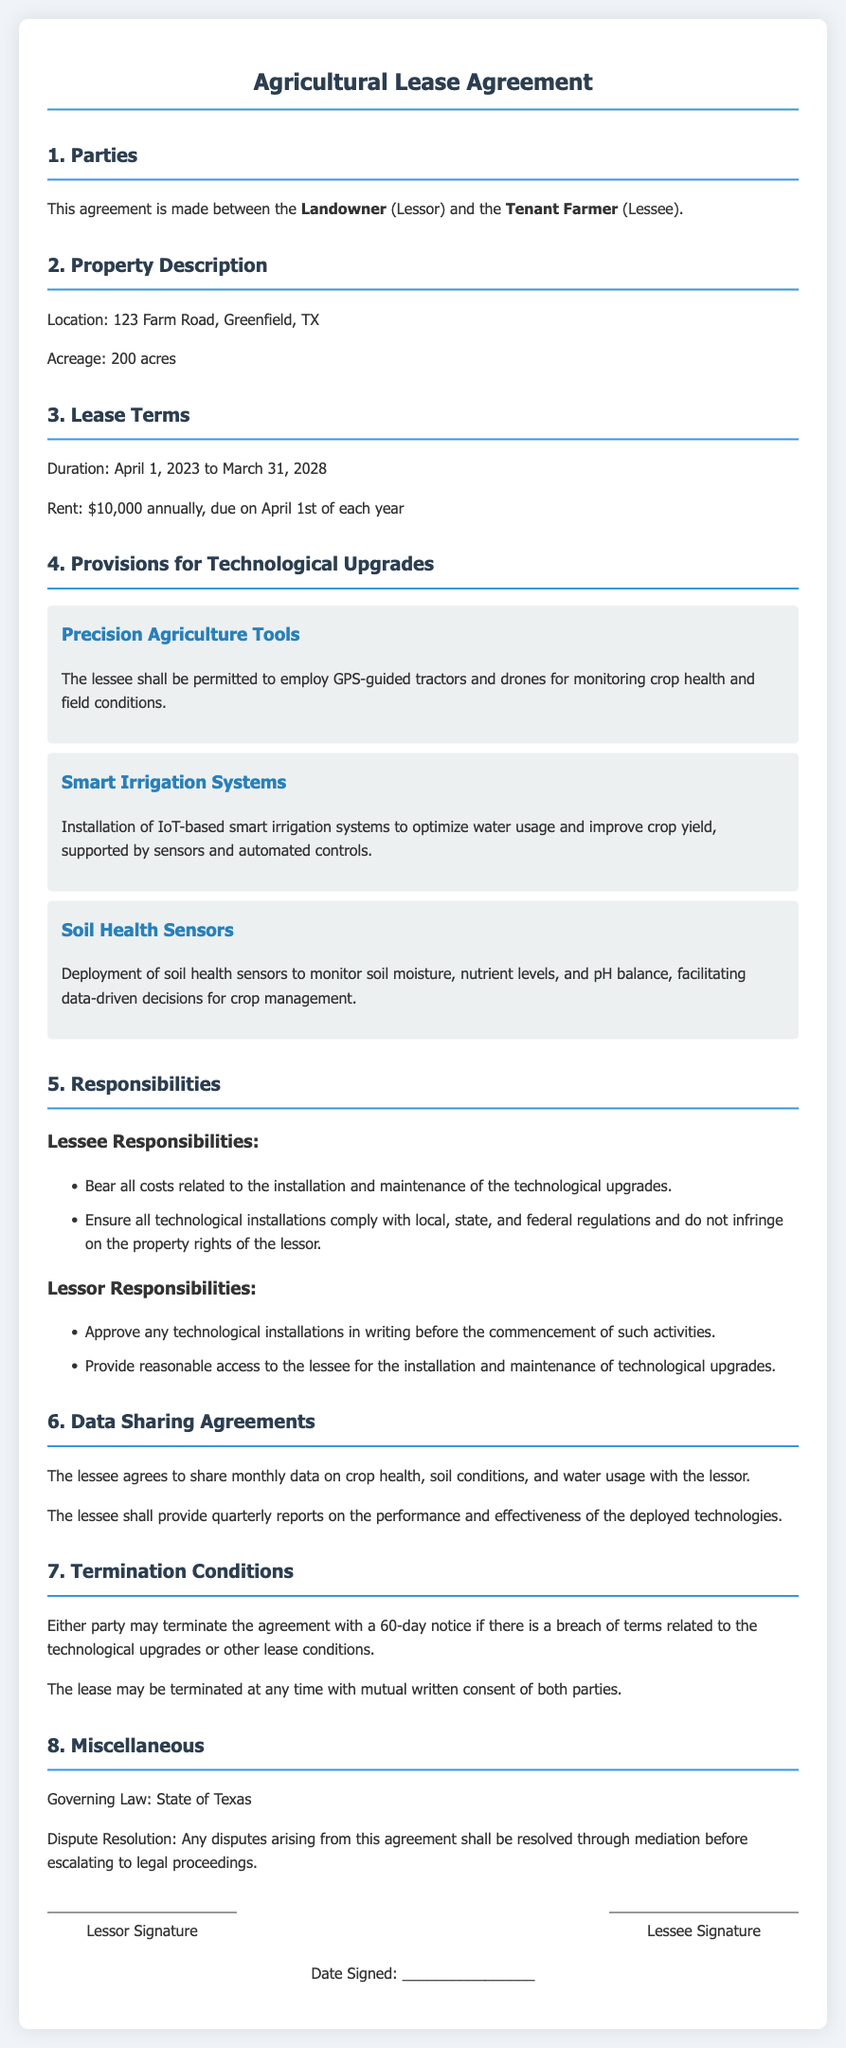What is the location of the property? The document states the location of the property is 123 Farm Road, Greenfield, TX.
Answer: 123 Farm Road, Greenfield, TX What is the duration of the lease? The lease duration is specified as starting April 1, 2023 to March 31, 2028.
Answer: April 1, 2023 to March 31, 2028 What is the annual rent amount? The document indicates the annual rent is $10,000.
Answer: $10,000 What are two responsibilities of the lessee? The responsibilities listed for the lessee include bearing all costs related to technological upgrades and ensuring compliance with regulations.
Answer: Bear all costs; Ensure compliance What type of irrigation system is mentioned? The document refers to the installation of IoT-based smart irrigation systems.
Answer: IoT-based smart irrigation systems What must the lessor provide for technological installations? The lessor is required to approve any technological installations in writing before commencement.
Answer: Written approval How often must the lessee share data with the lessor? The lessee agrees to share monthly data with the lessor.
Answer: Monthly What is the termination notice period? The document states that either party may terminate the agreement with a 60-day notice.
Answer: 60-day notice What technology is deployed to monitor soil conditions? The document mentions the deployment of soil health sensors.
Answer: Soil health sensors 